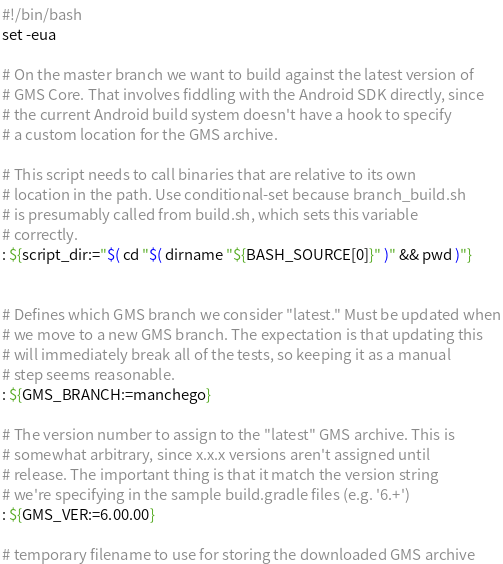<code> <loc_0><loc_0><loc_500><loc_500><_Bash_>#!/bin/bash
set -eua

# On the master branch we want to build against the latest version of
# GMS Core. That involves fiddling with the Android SDK directly, since
# the current Android build system doesn't have a hook to specify
# a custom location for the GMS archive.

# This script needs to call binaries that are relative to its own
# location in the path. Use conditional-set because branch_build.sh
# is presumably called from build.sh, which sets this variable
# correctly.
: ${script_dir:="$( cd "$( dirname "${BASH_SOURCE[0]}" )" && pwd )"}


# Defines which GMS branch we consider "latest." Must be updated when
# we move to a new GMS branch. The expectation is that updating this
# will immediately break all of the tests, so keeping it as a manual
# step seems reasonable.
: ${GMS_BRANCH:=manchego}

# The version number to assign to the "latest" GMS archive. This is
# somewhat arbitrary, since x.x.x versions aren't assigned until
# release. The important thing is that it match the version string
# we're specifying in the sample build.gradle files (e.g. '6.+')
: ${GMS_VER:=6.00.00}

# temporary filename to use for storing the downloaded GMS archive</code> 